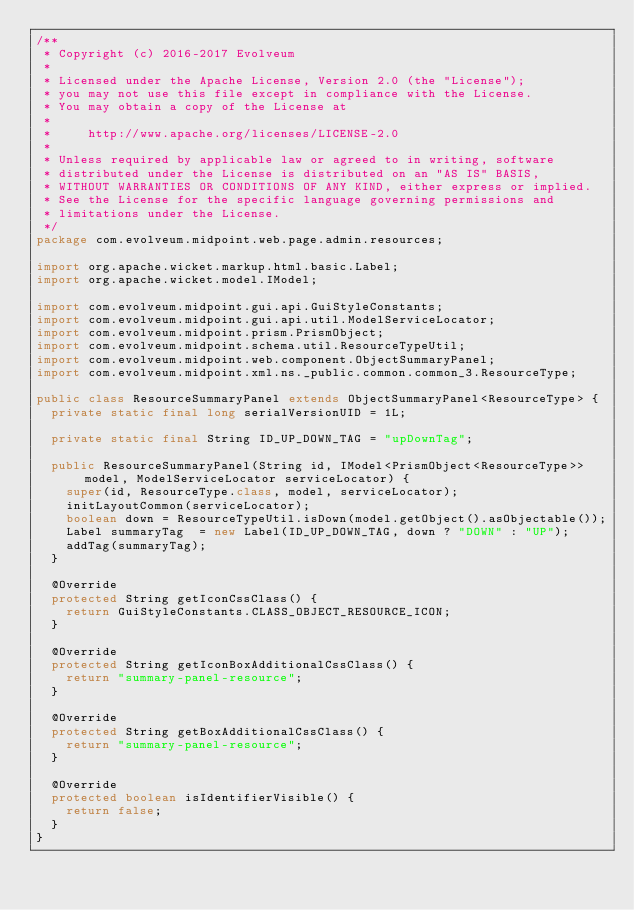Convert code to text. <code><loc_0><loc_0><loc_500><loc_500><_Java_>/**
 * Copyright (c) 2016-2017 Evolveum
 *
 * Licensed under the Apache License, Version 2.0 (the "License");
 * you may not use this file except in compliance with the License.
 * You may obtain a copy of the License at
 *
 *     http://www.apache.org/licenses/LICENSE-2.0
 *
 * Unless required by applicable law or agreed to in writing, software
 * distributed under the License is distributed on an "AS IS" BASIS,
 * WITHOUT WARRANTIES OR CONDITIONS OF ANY KIND, either express or implied.
 * See the License for the specific language governing permissions and
 * limitations under the License.
 */
package com.evolveum.midpoint.web.page.admin.resources;

import org.apache.wicket.markup.html.basic.Label;
import org.apache.wicket.model.IModel;

import com.evolveum.midpoint.gui.api.GuiStyleConstants;
import com.evolveum.midpoint.gui.api.util.ModelServiceLocator;
import com.evolveum.midpoint.prism.PrismObject;
import com.evolveum.midpoint.schema.util.ResourceTypeUtil;
import com.evolveum.midpoint.web.component.ObjectSummaryPanel;
import com.evolveum.midpoint.xml.ns._public.common.common_3.ResourceType;

public class ResourceSummaryPanel extends ObjectSummaryPanel<ResourceType> {
	private static final long serialVersionUID = 1L;

	private static final String ID_UP_DOWN_TAG = "upDownTag";

	public ResourceSummaryPanel(String id, IModel<PrismObject<ResourceType>> model, ModelServiceLocator serviceLocator) {
		super(id, ResourceType.class, model, serviceLocator);
		initLayoutCommon(serviceLocator);
		boolean down = ResourceTypeUtil.isDown(model.getObject().asObjectable());
		Label summaryTag  = new Label(ID_UP_DOWN_TAG, down ? "DOWN" : "UP");
		addTag(summaryTag);
	}

	@Override
	protected String getIconCssClass() {
		return GuiStyleConstants.CLASS_OBJECT_RESOURCE_ICON;
	}

	@Override
	protected String getIconBoxAdditionalCssClass() {
		return "summary-panel-resource";
	}

	@Override
	protected String getBoxAdditionalCssClass() {
		return "summary-panel-resource";
	}

	@Override
	protected boolean isIdentifierVisible() {
		return false;
	}
}
</code> 